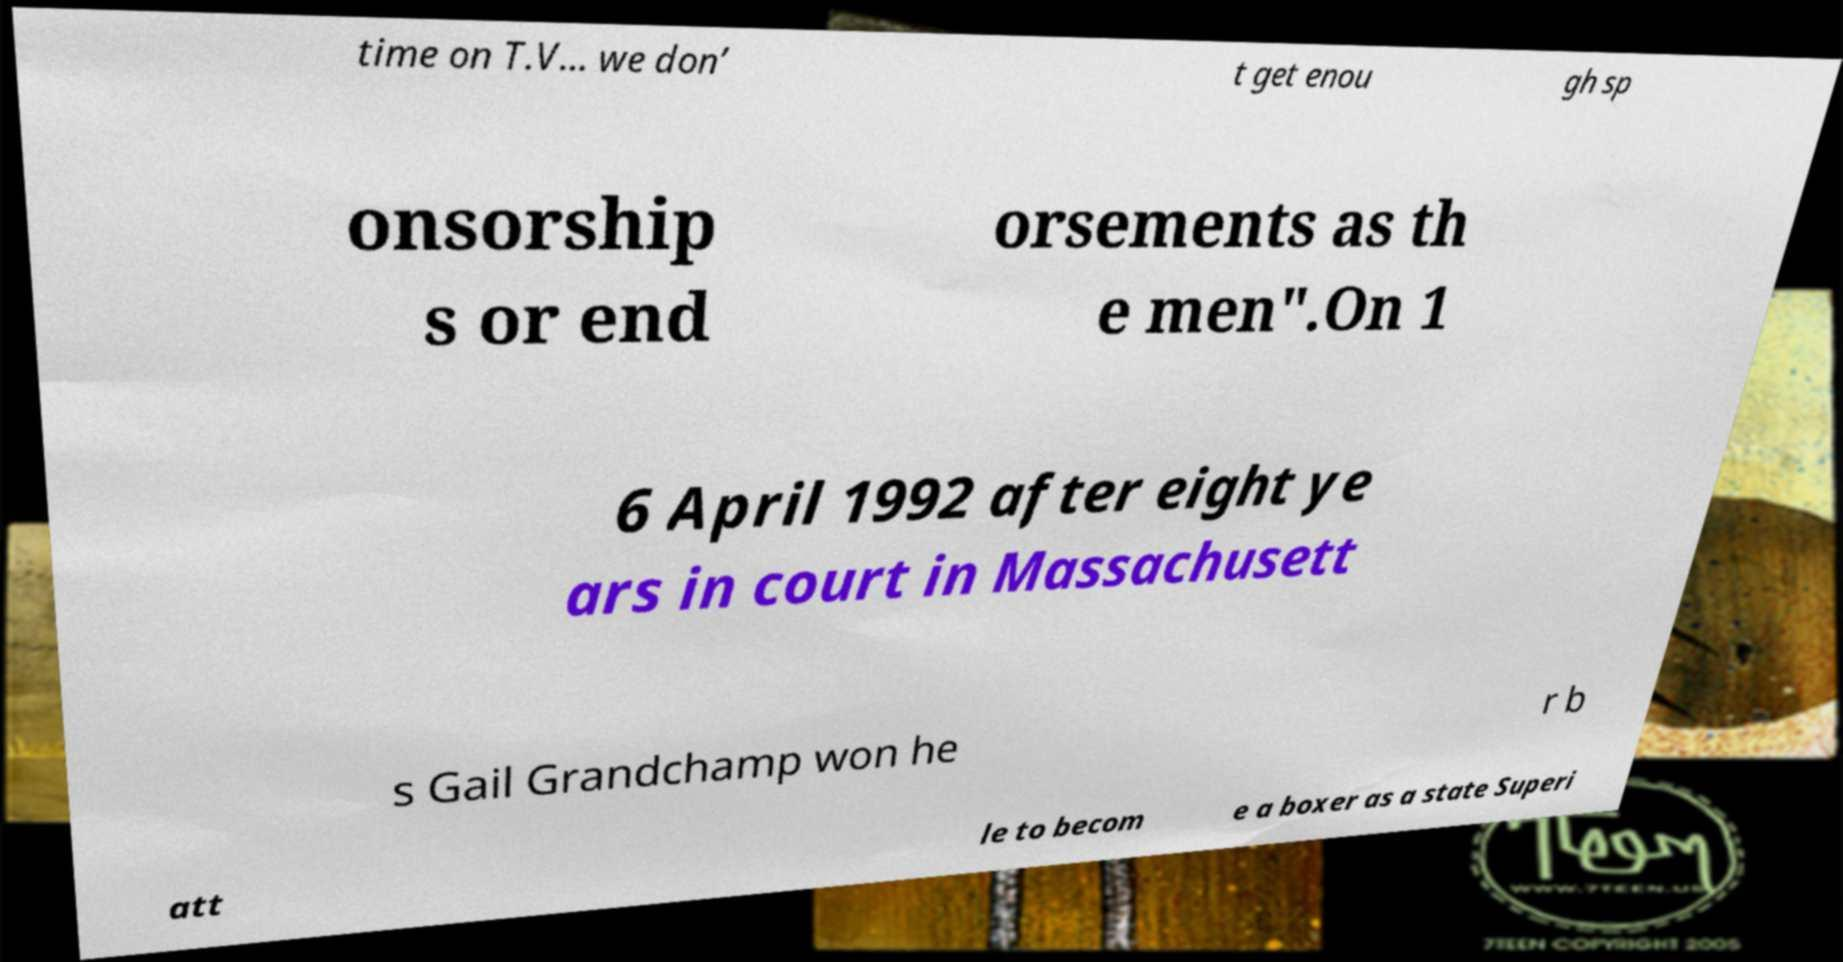For documentation purposes, I need the text within this image transcribed. Could you provide that? time on T.V… we don’ t get enou gh sp onsorship s or end orsements as th e men".On 1 6 April 1992 after eight ye ars in court in Massachusett s Gail Grandchamp won he r b att le to becom e a boxer as a state Superi 